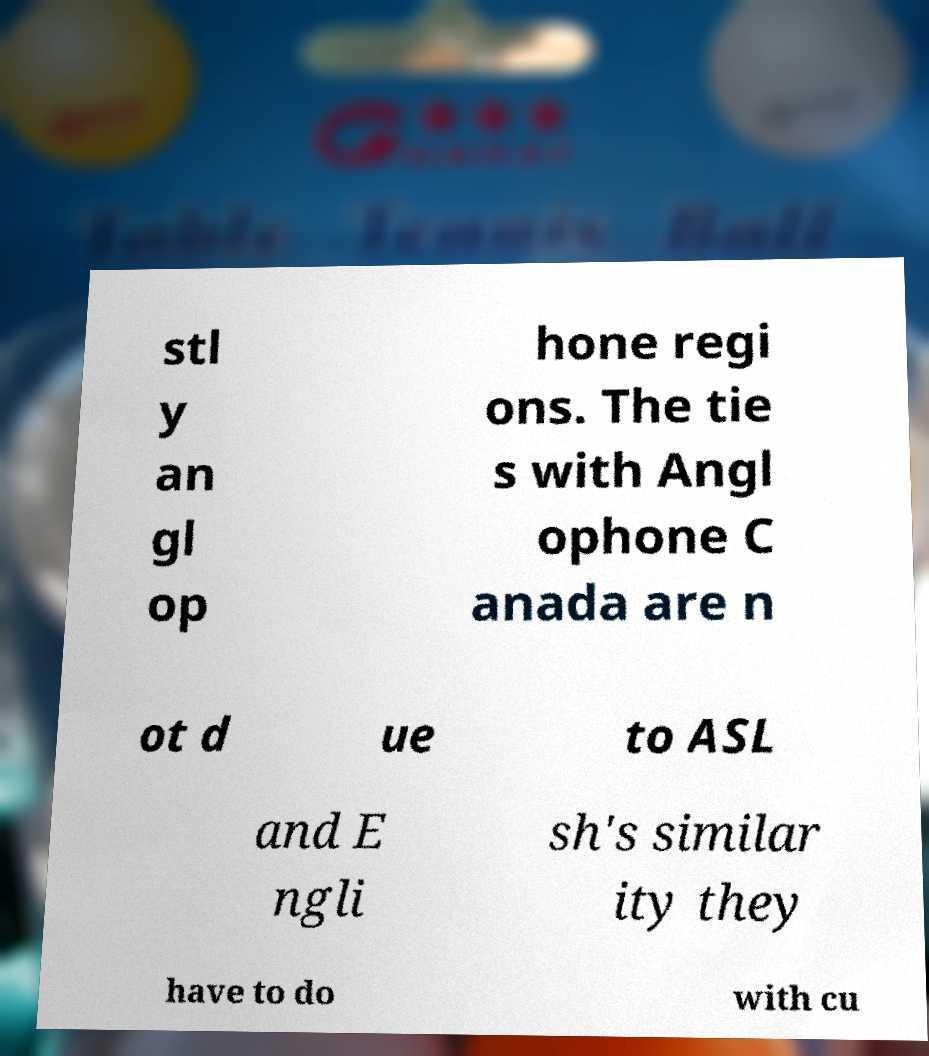Can you accurately transcribe the text from the provided image for me? stl y an gl op hone regi ons. The tie s with Angl ophone C anada are n ot d ue to ASL and E ngli sh's similar ity they have to do with cu 